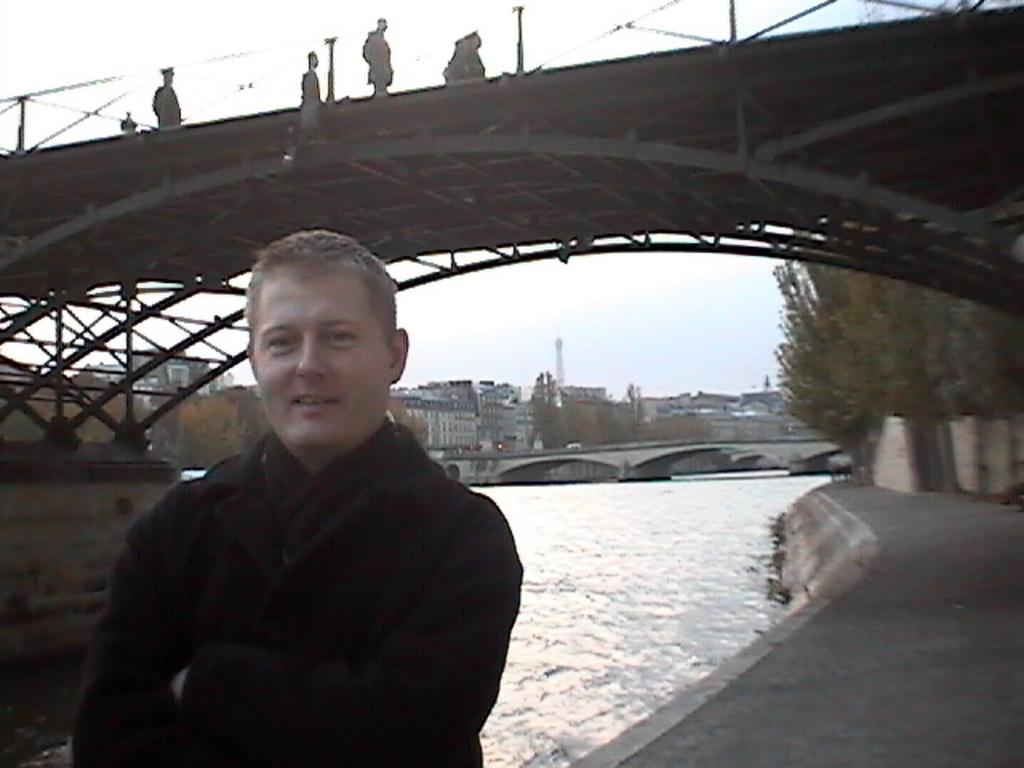What is the man in the image wearing? The man is wearing a black dress. What can be seen in the background of the image? There are trees and buildings in the background of the image. What is the man standing near in the image? There is a bridge in the image, and people are present on the bridge. What is visible in the image besides the man and the bridge? There is water visible in the image. What type of tail can be seen on the man in the image? There is no tail visible on the man in the image. What is the man using to drink milk in the image? There is no milk or any indication of the man drinking milk in the image. 